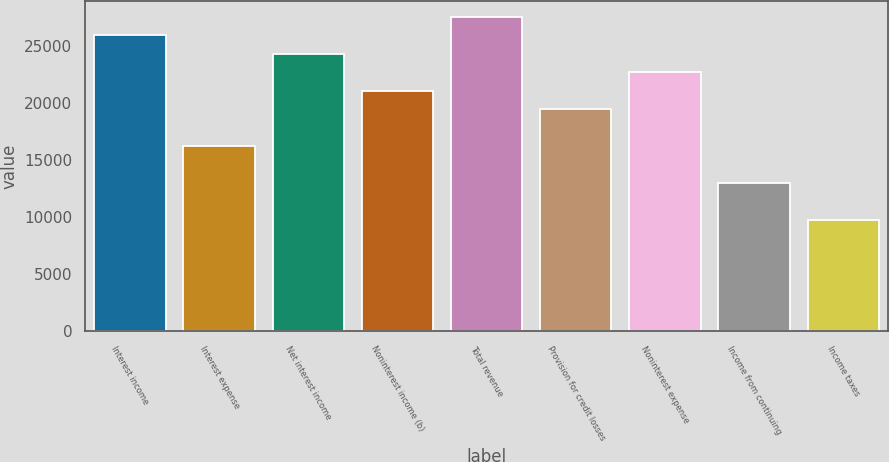Convert chart. <chart><loc_0><loc_0><loc_500><loc_500><bar_chart><fcel>Interest income<fcel>Interest expense<fcel>Net interest income<fcel>Noninterest income (b)<fcel>Total revenue<fcel>Provision for credit losses<fcel>Noninterest expense<fcel>Income from continuing<fcel>Income taxes<nl><fcel>25964.7<fcel>16228<fcel>24342<fcel>21096.4<fcel>27587.5<fcel>19473.6<fcel>22719.2<fcel>12982.4<fcel>9736.84<nl></chart> 